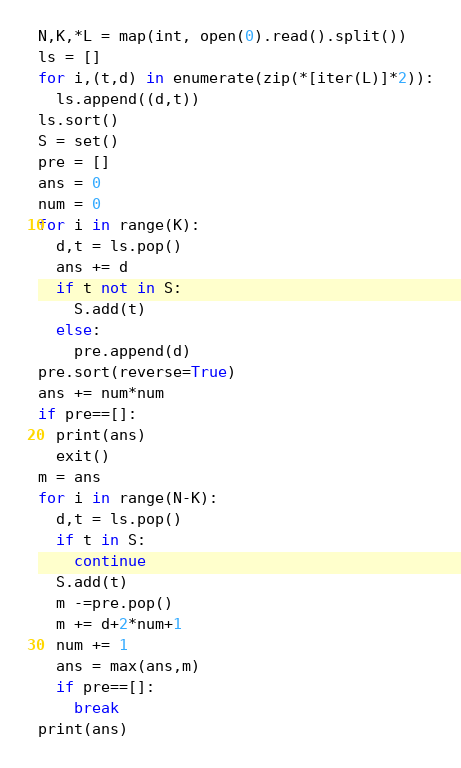Convert code to text. <code><loc_0><loc_0><loc_500><loc_500><_Python_>N,K,*L = map(int, open(0).read().split())
ls = []
for i,(t,d) in enumerate(zip(*[iter(L)]*2)):
  ls.append((d,t))
ls.sort()
S = set()
pre = []
ans = 0
num = 0
for i in range(K):
  d,t = ls.pop()
  ans += d
  if t not in S:
    S.add(t)
  else:
    pre.append(d)
pre.sort(reverse=True)
ans += num*num
if pre==[]:
  print(ans)
  exit()
m = ans
for i in range(N-K):
  d,t = ls.pop()
  if t in S:
    continue
  S.add(t)
  m -=pre.pop()
  m += d+2*num+1
  num += 1
  ans = max(ans,m)
  if pre==[]:
    break
print(ans)</code> 